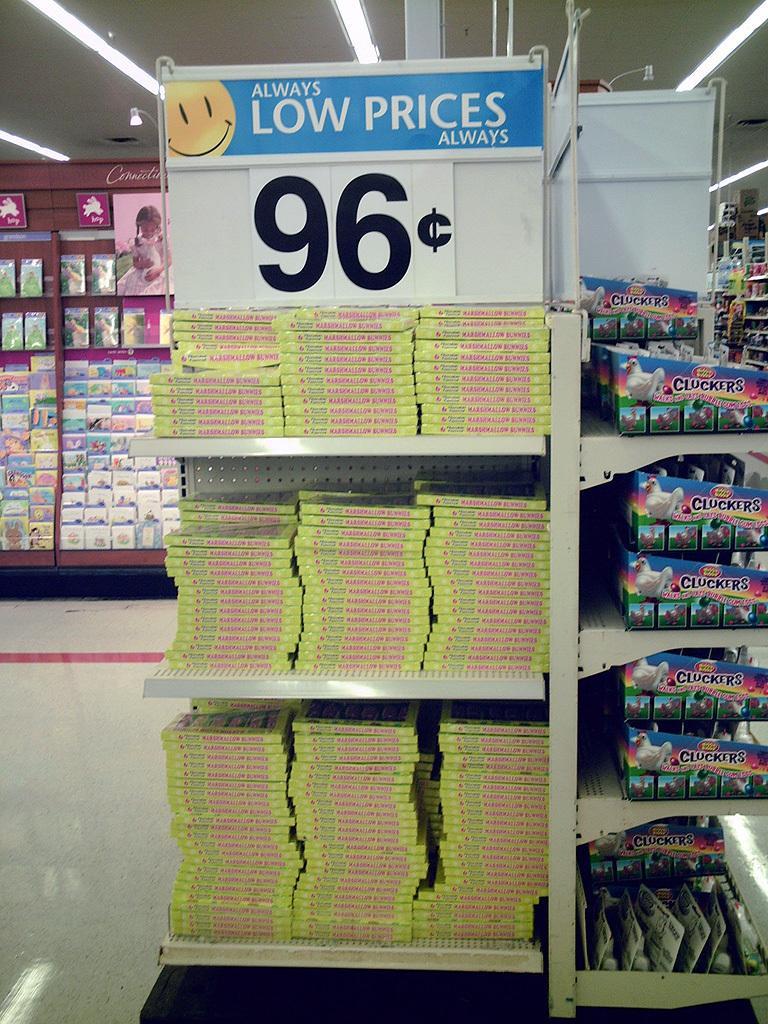Please provide a concise description of this image. In this image, we can see some shelves with objects. We can also see some boards with text and images. We can see the ground and the roof with some lights. We can also see some black colored object at the bottom. 